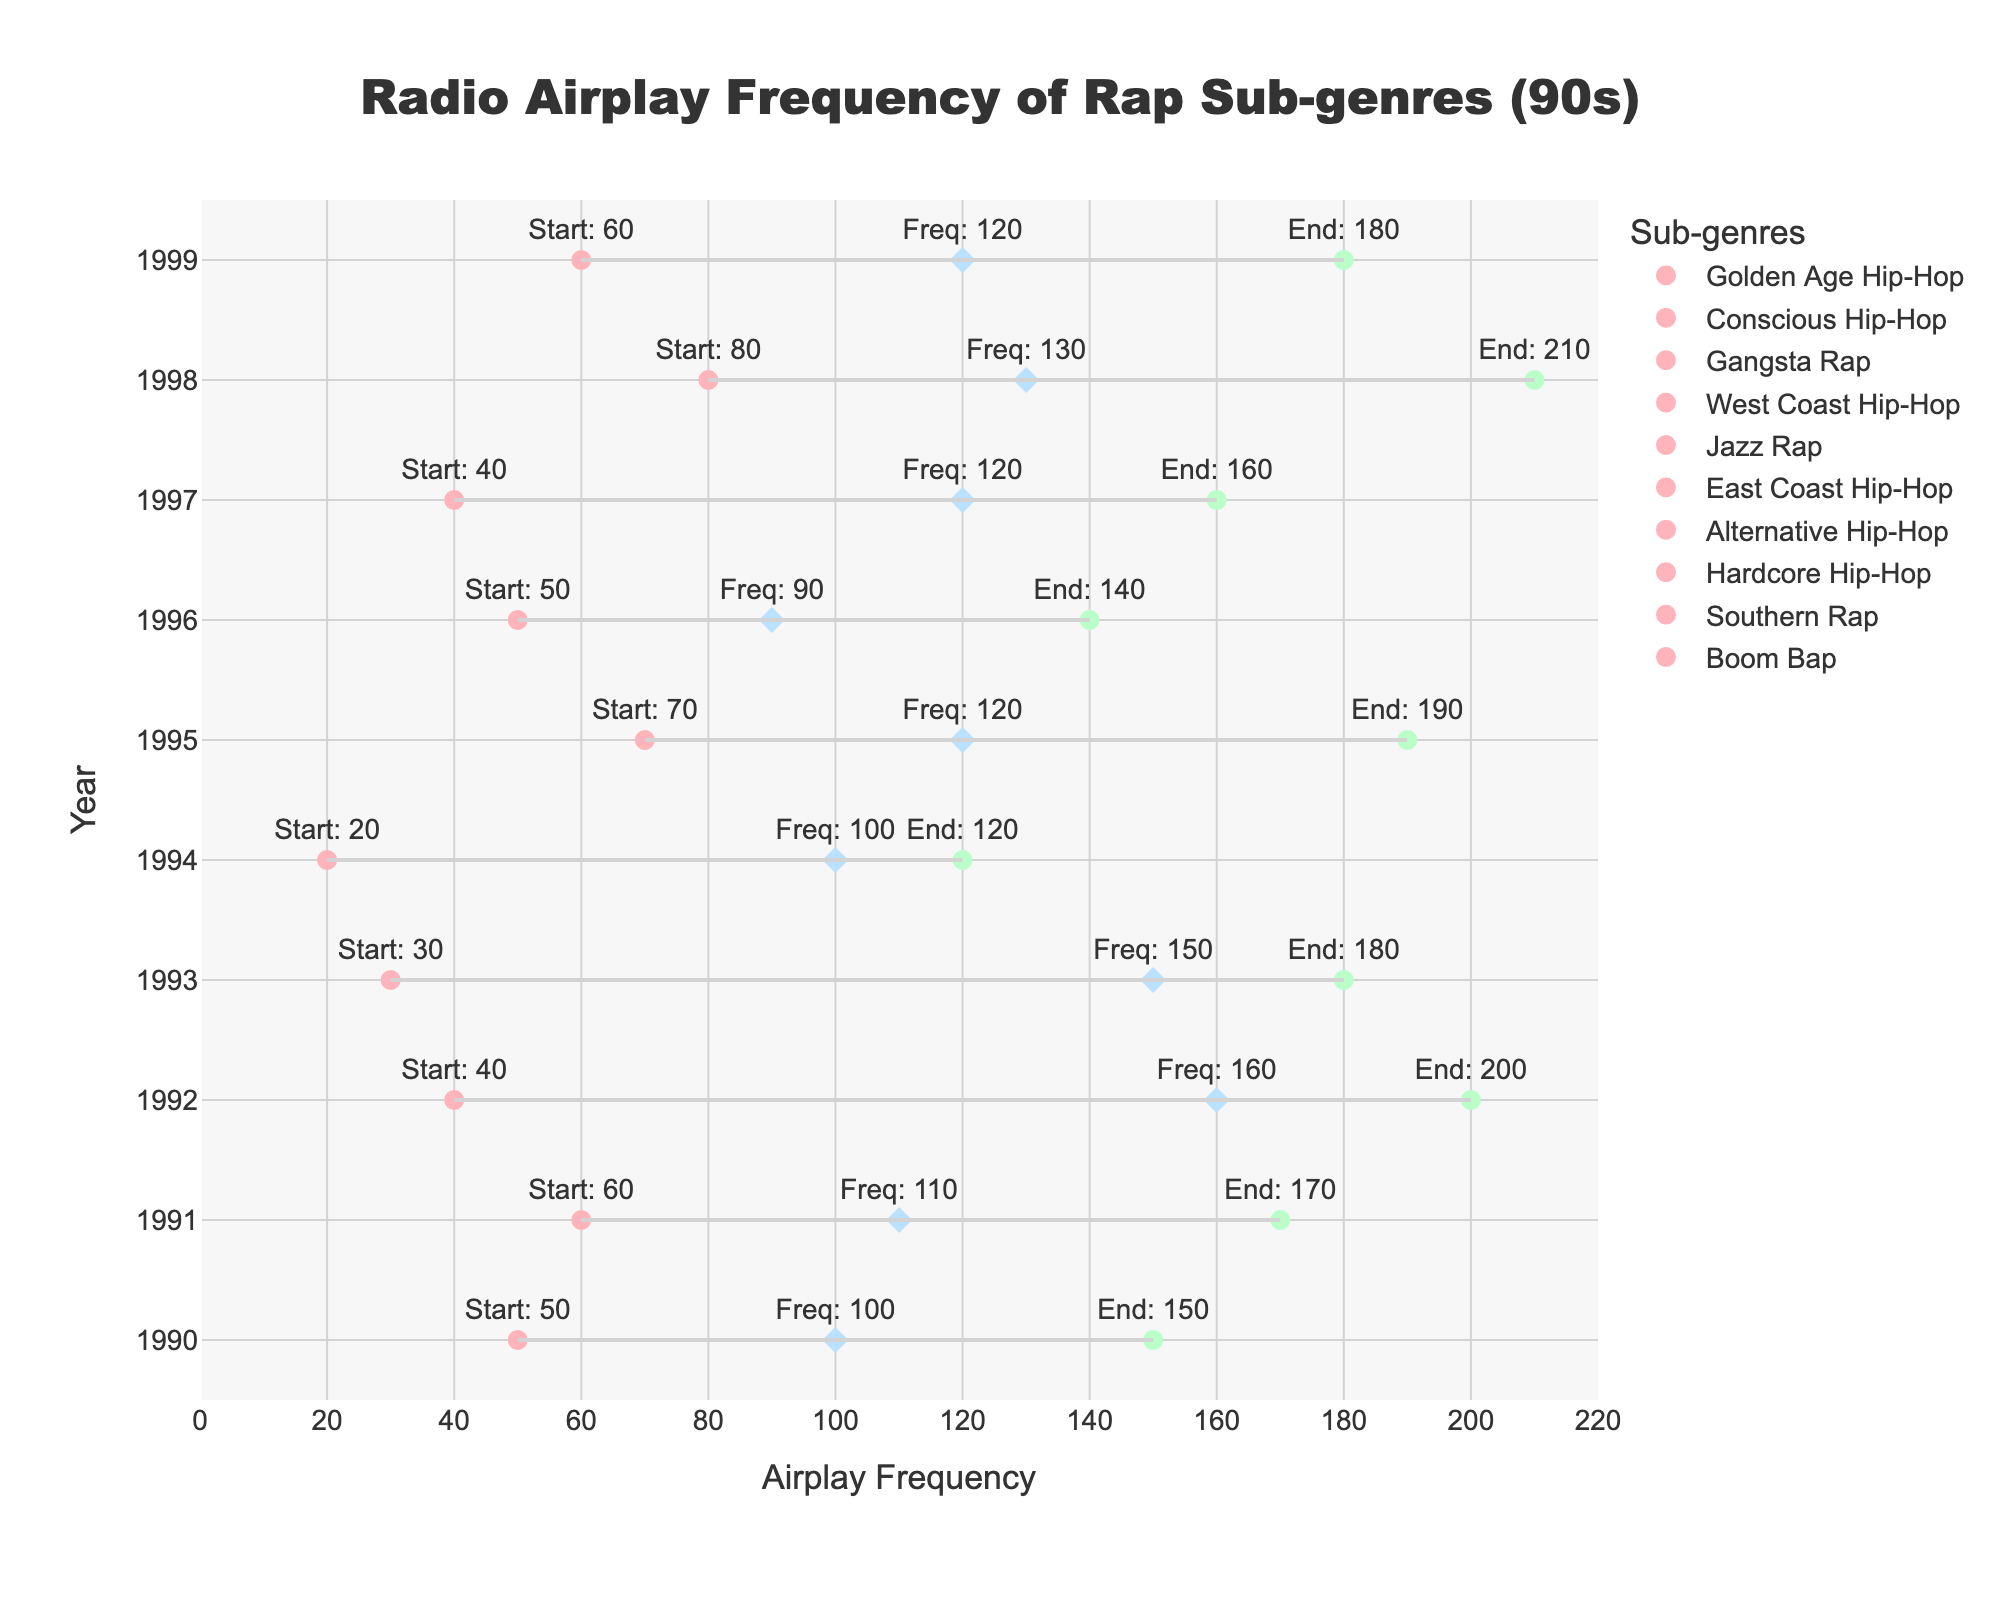Which sub-genre had the highest airplay frequency in the 90s? To determine the sub-genre with the highest airplay frequency, find the highest value in the "Airplay_Frequency" column. The highest value is 160. This frequency corresponds to Gangsta Rap by Dr. Dre in 1992.
Answer: Gangsta Rap Which year had the most diverse airplay frequencies? Examine the range of airplay frequencies for each year. For each year, subtract the smallest airplay frequency from the largest within that year. The largest range is from 40 to 200 in 1992 (Gangsta Rap), which is a range of 160, indicating that this year had the most diverse airplay frequencies.
Answer: 1992 What is the average airplay frequency for East Coast Hip-Hop and West Coast Hip-Hop combined? Find the airplay frequencies of East Coast Hip-Hop (120 in 1995) and West Coast Hip-Hop (150 in 1993), sum them up (120 + 150 = 270), and then divide by 2, resulting in an average of 135.
Answer: 135 In which year did Southern Rap receive its peak radio airplay? Look for the year associated with Southern Rap. Southern Rap, represented by OutKast, has its data point in 1998 with a peak airplay frequency of 210.
Answer: 1998 How long was Gangsta Rap played on the radio in 1992? To find the duration of airplay for Gangsta Rap in 1992, subtract the start airplay value from the end airplay value. For Gangsta Rap by Dr. Dre in 1992, the start airplay was 40 and end airplay was 200, so the duration is 200 - 40 = 160.
Answer: 160 What was the airplay frequency difference between Jazz Rap and Hardcore Hip-Hop? Find the airplay frequencies for Jazz Rap (100 in 1994) and Hardcore Hip-Hop (120 in 1997). Subtract the Jazz Rap frequency from the Hardcore Hip-Hop frequency (120 - 100 = 20).
Answer: 20 Which sub-genre had a higher airplay frequency in 1995, Alternative Hip-Hop or Golden Age Hip-Hop? Compare the airplay frequencies for the respective years: Alternative Hip-Hop in 1996 had a frequency of 90, while Golden Age Hip-Hop in 1990 had a frequency of 100. Therefore, Golden Age Hip-Hop had a higher airplay frequency.
Answer: Golden Age Hip-Hop What is the total airplay duration for all sub-genres in the 90s? Sum up the airplay durations for all sub-genres over the decade by subtracting the start airplay from the end airplay for each entry and summing them. The durations are: 100, 110, 160, 150, 100, 120, 90, 120, 130, 120. Total duration is 100 + 110 + 160 + 150 + 100 + 120 + 90 + 120 + 130 + 120 = 1200.
Answer: 1200 Which year saw the highest average airplay frequency among all the represented sub-genres? Calculate the average airplay frequency for each year by summing the airplay frequencies of sub-genres in that year and dividing by the number of sub-genres for that year. The year-by-year averages should be calculated and compared: 
- 1990: 100
- 1991: 110
- 1992: 160
- 1993: 150
- 1994: 100
- 1995: 120
- 1996: 90
- 1997: 120
- 1998: 130
- 1999: 120
1992 had the highest average airplay frequency of 160.
Answer: 1992 